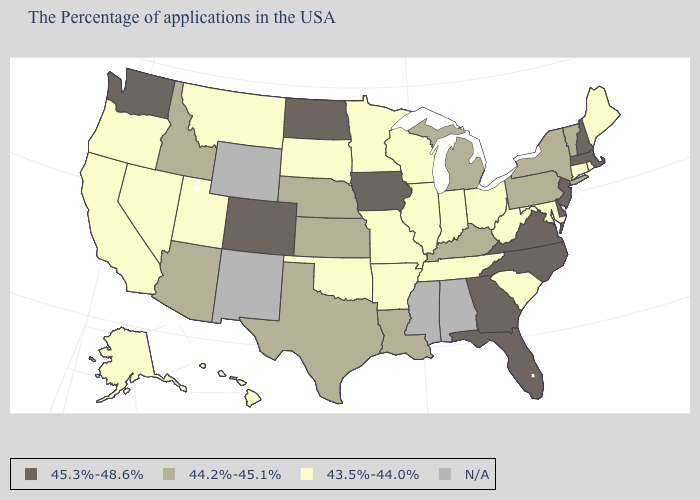Does Nevada have the lowest value in the West?
Give a very brief answer. Yes. What is the value of South Carolina?
Quick response, please. 43.5%-44.0%. What is the value of Pennsylvania?
Concise answer only. 44.2%-45.1%. What is the lowest value in the West?
Short answer required. 43.5%-44.0%. Which states have the lowest value in the West?
Short answer required. Utah, Montana, Nevada, California, Oregon, Alaska, Hawaii. Does New Hampshire have the lowest value in the USA?
Be succinct. No. Name the states that have a value in the range N/A?
Keep it brief. Alabama, Mississippi, Wyoming, New Mexico. Among the states that border Utah , which have the highest value?
Keep it brief. Colorado. Among the states that border Oregon , which have the highest value?
Give a very brief answer. Washington. Name the states that have a value in the range 44.2%-45.1%?
Quick response, please. Vermont, New York, Pennsylvania, Michigan, Kentucky, Louisiana, Kansas, Nebraska, Texas, Arizona, Idaho. How many symbols are there in the legend?
Concise answer only. 4. Name the states that have a value in the range N/A?
Give a very brief answer. Alabama, Mississippi, Wyoming, New Mexico. What is the lowest value in the USA?
Quick response, please. 43.5%-44.0%. 